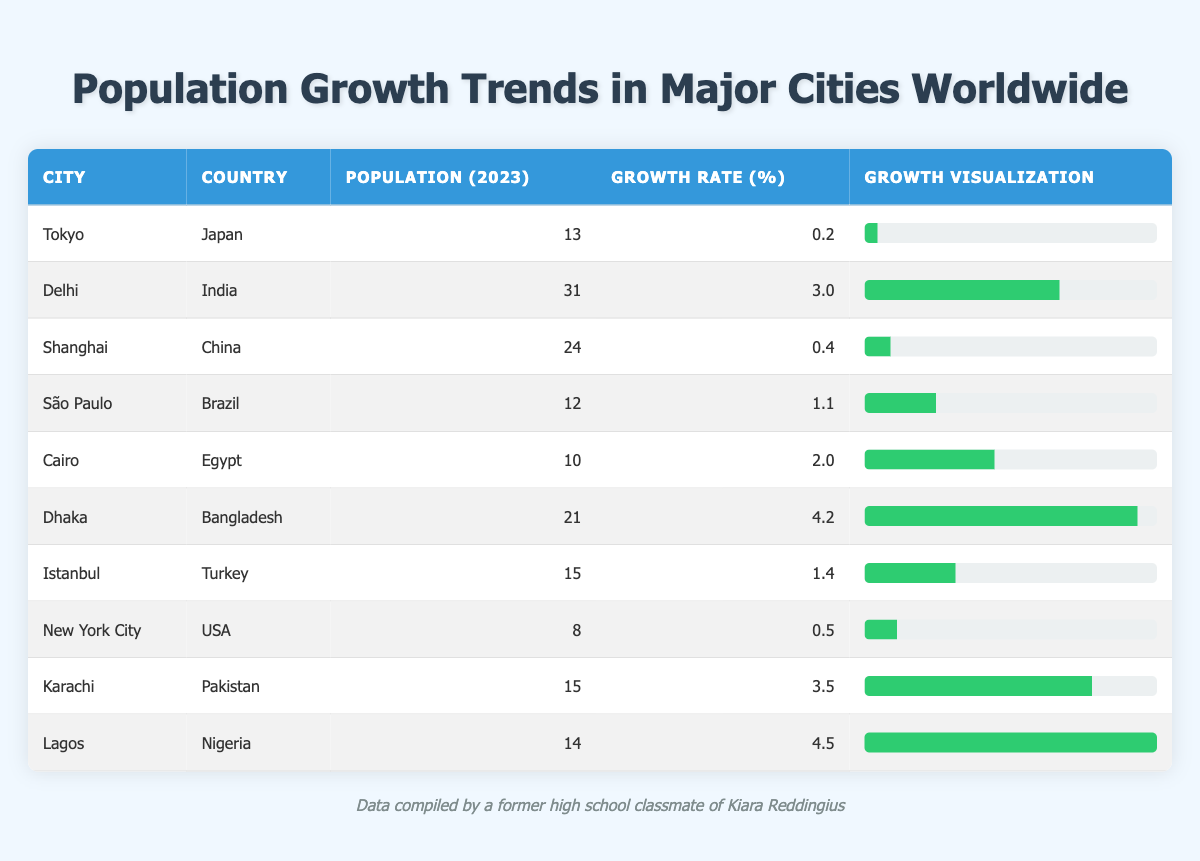What is the population of Delhi in 2023? The table shows that the population of Delhi in 2023 is listed right next to the city's name under the "Population (2023)" column. Looking at that column, you can see the figure is 31,181,000.
Answer: 31,181,000 Which city has the highest population growth rate? To find out which city has the highest growth rate, I look at the "Growth Rate (%)" column and find the maximum value. The highest growth rate is 4.5%, which corresponds to Lagos.
Answer: Lagos What is the combined population of Cairo and São Paulo? First, I find the population of Cairo, which is 10,950,000, and São Paulo, which is 12,330,000. I then add these two values together: 10,950,000 + 12,330,000 = 23,280,000.
Answer: 23,280,000 Is the growth rate of New York City higher than that of Tokyo? I compare the growth rates from the "Growth Rate (%)" column. New York City has a growth rate of 0.5%, while Tokyo has a growth rate of 0.2%. Since 0.5% is greater than 0.2%, the statement is true.
Answer: Yes What is the average population growth rate of the cities listed? I first sum up the growth rates for all the cities: 0.2 + 3.0 + 0.4 + 1.1 + 2.0 + 4.2 + 1.4 + 0.5 + 3.5 + 4.5 = 21.4%. There are 10 cities listed, so I divide the total growth rate by 10 to find the average: 21.4 / 10 = 2.14.
Answer: 2.14 Which country has the city with the lowest population? Looking at the "Population (2023)" column, I find the smallest value, which is 8,419,000 for New York City. The corresponding country is the USA.
Answer: USA What is the percentage difference in population between Dhaka and Lagos? First, we determine the populations: Dhaka has 21,800,000 and Lagos has 14,900,000. The difference in their populations is 21,800,000 - 14,900,000 = 6,900,000. To find the percentage difference relative to Dhaka's population, we use the formula: (6,900,000 / 21,800,000) * 100 ≈ 31.6%.
Answer: 31.6% Is the population of Shanghai more than the combined population of New York City and Tokyo? The population of Shanghai is 24,183,300. The combined population of New York City (8,419,000) and Tokyo (13,929,286) is 21,348,286. Comparing, 24,183,300 is greater than 21,348,286, thus, the statement is true.
Answer: Yes 